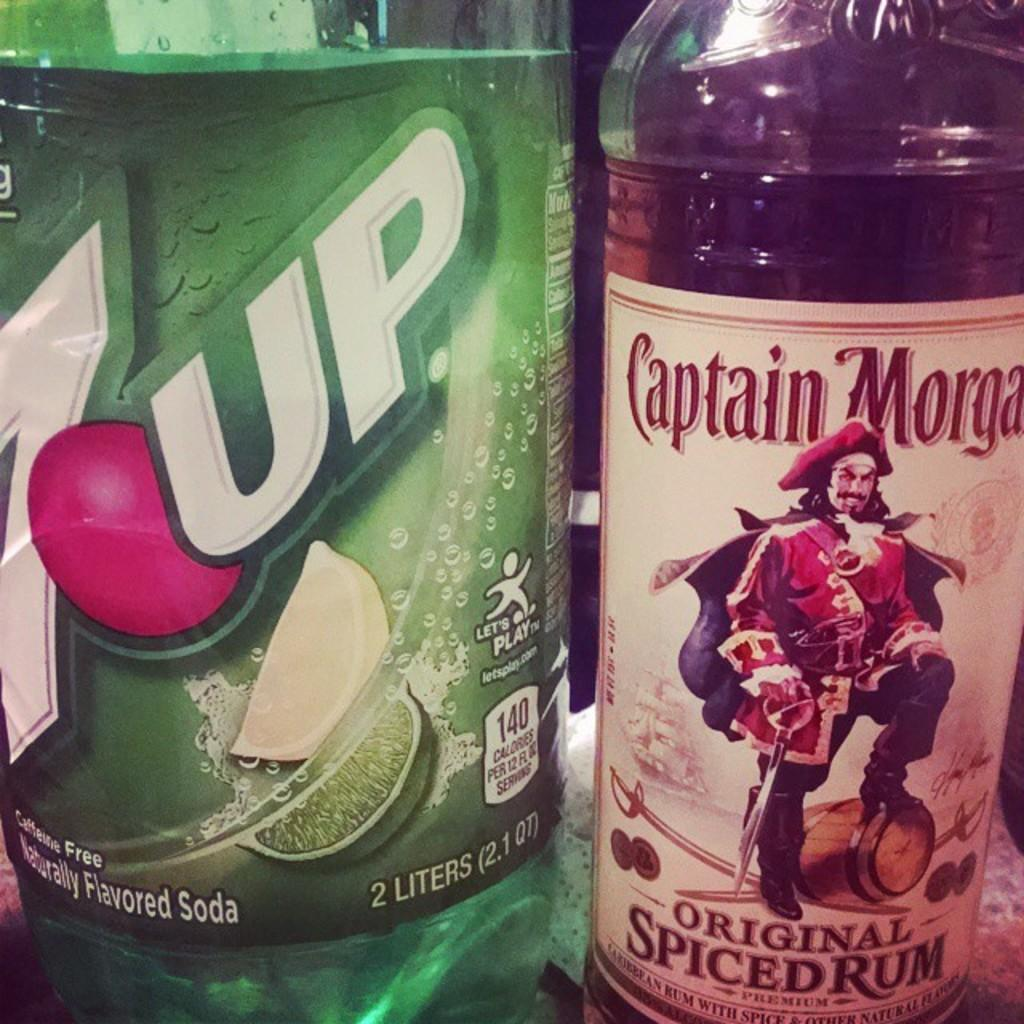Provide a one-sentence caption for the provided image. A 2 liter bottle of 7 Up is on a counter by a bottle of Captain Morgan. 